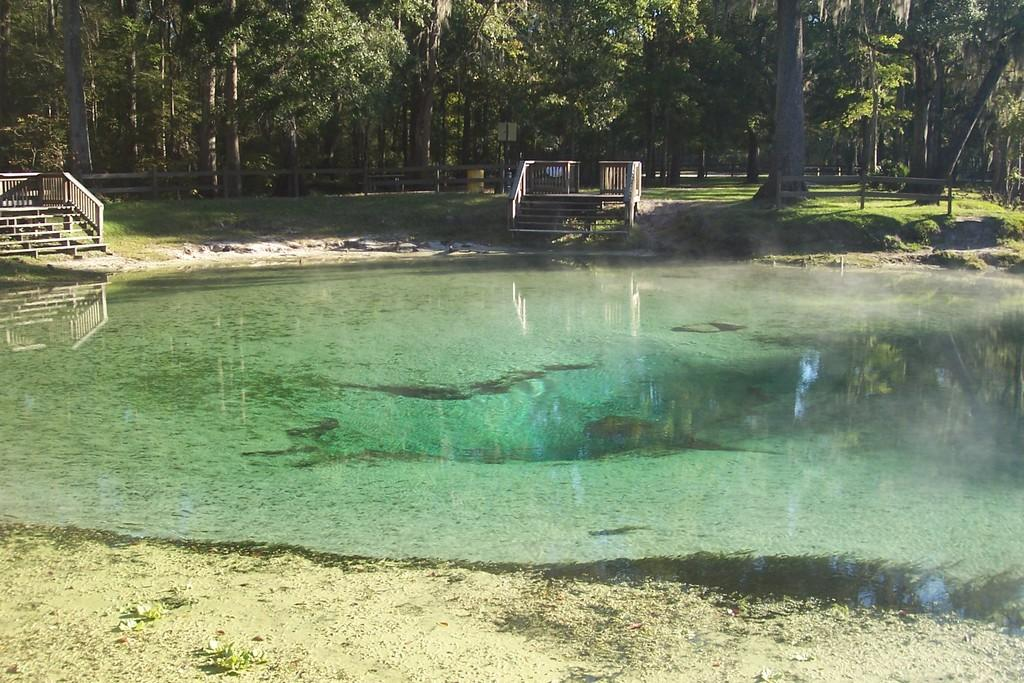What can be seen at the bottom of the image? There is water and land at the bottom of the image. What features are present in the middle of the image? There are staircases, grass, trees, benches, and a fence in the middle of the image. Can you see a nut being cracked by a squirrel on one of the benches in the image? There is no nut or squirrel present in the image. Is there a sister sitting on one of the benches in the image? There is no mention of a sister or anyone sitting on the benches in the image. 